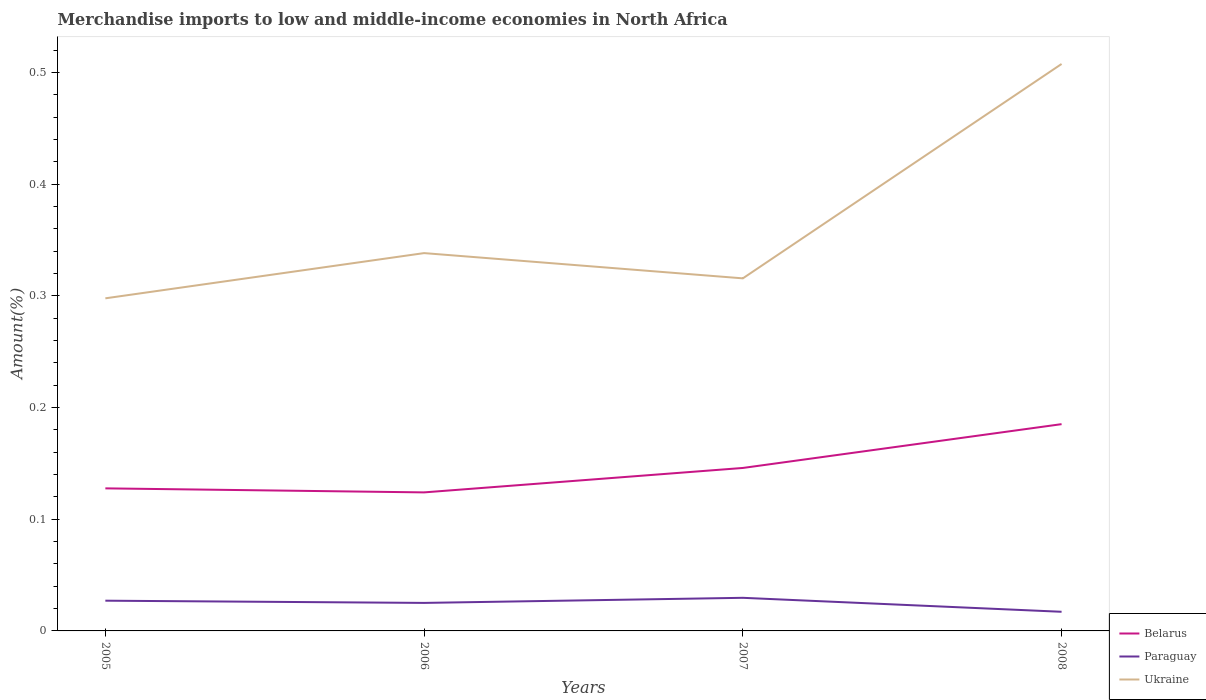How many different coloured lines are there?
Provide a succinct answer. 3. Across all years, what is the maximum percentage of amount earned from merchandise imports in Belarus?
Provide a short and direct response. 0.12. In which year was the percentage of amount earned from merchandise imports in Paraguay maximum?
Make the answer very short. 2008. What is the total percentage of amount earned from merchandise imports in Paraguay in the graph?
Keep it short and to the point. -0. What is the difference between the highest and the second highest percentage of amount earned from merchandise imports in Paraguay?
Make the answer very short. 0.01. What is the difference between the highest and the lowest percentage of amount earned from merchandise imports in Belarus?
Offer a very short reply. 2. Are the values on the major ticks of Y-axis written in scientific E-notation?
Keep it short and to the point. No. Does the graph contain any zero values?
Offer a very short reply. No. Does the graph contain grids?
Offer a terse response. No. Where does the legend appear in the graph?
Offer a very short reply. Bottom right. How many legend labels are there?
Your answer should be very brief. 3. What is the title of the graph?
Offer a very short reply. Merchandise imports to low and middle-income economies in North Africa. What is the label or title of the X-axis?
Make the answer very short. Years. What is the label or title of the Y-axis?
Offer a terse response. Amount(%). What is the Amount(%) of Belarus in 2005?
Keep it short and to the point. 0.13. What is the Amount(%) in Paraguay in 2005?
Provide a succinct answer. 0.03. What is the Amount(%) of Ukraine in 2005?
Your answer should be compact. 0.3. What is the Amount(%) of Belarus in 2006?
Make the answer very short. 0.12. What is the Amount(%) in Paraguay in 2006?
Provide a succinct answer. 0.03. What is the Amount(%) of Ukraine in 2006?
Offer a very short reply. 0.34. What is the Amount(%) in Belarus in 2007?
Ensure brevity in your answer.  0.15. What is the Amount(%) in Paraguay in 2007?
Offer a very short reply. 0.03. What is the Amount(%) in Ukraine in 2007?
Offer a very short reply. 0.32. What is the Amount(%) of Belarus in 2008?
Your response must be concise. 0.19. What is the Amount(%) in Paraguay in 2008?
Your answer should be very brief. 0.02. What is the Amount(%) in Ukraine in 2008?
Offer a terse response. 0.51. Across all years, what is the maximum Amount(%) in Belarus?
Provide a short and direct response. 0.19. Across all years, what is the maximum Amount(%) in Paraguay?
Keep it short and to the point. 0.03. Across all years, what is the maximum Amount(%) of Ukraine?
Offer a very short reply. 0.51. Across all years, what is the minimum Amount(%) in Belarus?
Provide a short and direct response. 0.12. Across all years, what is the minimum Amount(%) in Paraguay?
Provide a succinct answer. 0.02. Across all years, what is the minimum Amount(%) in Ukraine?
Your answer should be very brief. 0.3. What is the total Amount(%) of Belarus in the graph?
Your answer should be compact. 0.58. What is the total Amount(%) of Paraguay in the graph?
Provide a succinct answer. 0.1. What is the total Amount(%) in Ukraine in the graph?
Your answer should be very brief. 1.46. What is the difference between the Amount(%) of Belarus in 2005 and that in 2006?
Provide a succinct answer. 0. What is the difference between the Amount(%) of Paraguay in 2005 and that in 2006?
Offer a terse response. 0. What is the difference between the Amount(%) of Ukraine in 2005 and that in 2006?
Offer a terse response. -0.04. What is the difference between the Amount(%) of Belarus in 2005 and that in 2007?
Offer a very short reply. -0.02. What is the difference between the Amount(%) in Paraguay in 2005 and that in 2007?
Your answer should be compact. -0. What is the difference between the Amount(%) of Ukraine in 2005 and that in 2007?
Your response must be concise. -0.02. What is the difference between the Amount(%) in Belarus in 2005 and that in 2008?
Offer a terse response. -0.06. What is the difference between the Amount(%) in Paraguay in 2005 and that in 2008?
Make the answer very short. 0.01. What is the difference between the Amount(%) of Ukraine in 2005 and that in 2008?
Your response must be concise. -0.21. What is the difference between the Amount(%) in Belarus in 2006 and that in 2007?
Provide a short and direct response. -0.02. What is the difference between the Amount(%) of Paraguay in 2006 and that in 2007?
Provide a succinct answer. -0. What is the difference between the Amount(%) in Ukraine in 2006 and that in 2007?
Provide a succinct answer. 0.02. What is the difference between the Amount(%) in Belarus in 2006 and that in 2008?
Offer a very short reply. -0.06. What is the difference between the Amount(%) of Paraguay in 2006 and that in 2008?
Keep it short and to the point. 0.01. What is the difference between the Amount(%) of Ukraine in 2006 and that in 2008?
Your response must be concise. -0.17. What is the difference between the Amount(%) in Belarus in 2007 and that in 2008?
Keep it short and to the point. -0.04. What is the difference between the Amount(%) in Paraguay in 2007 and that in 2008?
Provide a short and direct response. 0.01. What is the difference between the Amount(%) in Ukraine in 2007 and that in 2008?
Provide a short and direct response. -0.19. What is the difference between the Amount(%) of Belarus in 2005 and the Amount(%) of Paraguay in 2006?
Make the answer very short. 0.1. What is the difference between the Amount(%) in Belarus in 2005 and the Amount(%) in Ukraine in 2006?
Your response must be concise. -0.21. What is the difference between the Amount(%) in Paraguay in 2005 and the Amount(%) in Ukraine in 2006?
Offer a very short reply. -0.31. What is the difference between the Amount(%) in Belarus in 2005 and the Amount(%) in Paraguay in 2007?
Your answer should be very brief. 0.1. What is the difference between the Amount(%) of Belarus in 2005 and the Amount(%) of Ukraine in 2007?
Make the answer very short. -0.19. What is the difference between the Amount(%) in Paraguay in 2005 and the Amount(%) in Ukraine in 2007?
Ensure brevity in your answer.  -0.29. What is the difference between the Amount(%) in Belarus in 2005 and the Amount(%) in Paraguay in 2008?
Provide a short and direct response. 0.11. What is the difference between the Amount(%) of Belarus in 2005 and the Amount(%) of Ukraine in 2008?
Provide a short and direct response. -0.38. What is the difference between the Amount(%) in Paraguay in 2005 and the Amount(%) in Ukraine in 2008?
Ensure brevity in your answer.  -0.48. What is the difference between the Amount(%) of Belarus in 2006 and the Amount(%) of Paraguay in 2007?
Keep it short and to the point. 0.09. What is the difference between the Amount(%) of Belarus in 2006 and the Amount(%) of Ukraine in 2007?
Ensure brevity in your answer.  -0.19. What is the difference between the Amount(%) in Paraguay in 2006 and the Amount(%) in Ukraine in 2007?
Keep it short and to the point. -0.29. What is the difference between the Amount(%) of Belarus in 2006 and the Amount(%) of Paraguay in 2008?
Give a very brief answer. 0.11. What is the difference between the Amount(%) in Belarus in 2006 and the Amount(%) in Ukraine in 2008?
Offer a terse response. -0.38. What is the difference between the Amount(%) in Paraguay in 2006 and the Amount(%) in Ukraine in 2008?
Provide a succinct answer. -0.48. What is the difference between the Amount(%) of Belarus in 2007 and the Amount(%) of Paraguay in 2008?
Your response must be concise. 0.13. What is the difference between the Amount(%) of Belarus in 2007 and the Amount(%) of Ukraine in 2008?
Your response must be concise. -0.36. What is the difference between the Amount(%) in Paraguay in 2007 and the Amount(%) in Ukraine in 2008?
Your response must be concise. -0.48. What is the average Amount(%) in Belarus per year?
Your response must be concise. 0.15. What is the average Amount(%) of Paraguay per year?
Your answer should be very brief. 0.02. What is the average Amount(%) of Ukraine per year?
Make the answer very short. 0.36. In the year 2005, what is the difference between the Amount(%) of Belarus and Amount(%) of Paraguay?
Your answer should be very brief. 0.1. In the year 2005, what is the difference between the Amount(%) in Belarus and Amount(%) in Ukraine?
Keep it short and to the point. -0.17. In the year 2005, what is the difference between the Amount(%) in Paraguay and Amount(%) in Ukraine?
Make the answer very short. -0.27. In the year 2006, what is the difference between the Amount(%) of Belarus and Amount(%) of Paraguay?
Make the answer very short. 0.1. In the year 2006, what is the difference between the Amount(%) in Belarus and Amount(%) in Ukraine?
Ensure brevity in your answer.  -0.21. In the year 2006, what is the difference between the Amount(%) in Paraguay and Amount(%) in Ukraine?
Provide a short and direct response. -0.31. In the year 2007, what is the difference between the Amount(%) in Belarus and Amount(%) in Paraguay?
Provide a short and direct response. 0.12. In the year 2007, what is the difference between the Amount(%) in Belarus and Amount(%) in Ukraine?
Provide a short and direct response. -0.17. In the year 2007, what is the difference between the Amount(%) in Paraguay and Amount(%) in Ukraine?
Provide a short and direct response. -0.29. In the year 2008, what is the difference between the Amount(%) in Belarus and Amount(%) in Paraguay?
Provide a short and direct response. 0.17. In the year 2008, what is the difference between the Amount(%) of Belarus and Amount(%) of Ukraine?
Your answer should be very brief. -0.32. In the year 2008, what is the difference between the Amount(%) of Paraguay and Amount(%) of Ukraine?
Keep it short and to the point. -0.49. What is the ratio of the Amount(%) in Belarus in 2005 to that in 2006?
Keep it short and to the point. 1.03. What is the ratio of the Amount(%) in Paraguay in 2005 to that in 2006?
Ensure brevity in your answer.  1.08. What is the ratio of the Amount(%) in Ukraine in 2005 to that in 2006?
Make the answer very short. 0.88. What is the ratio of the Amount(%) in Belarus in 2005 to that in 2007?
Ensure brevity in your answer.  0.87. What is the ratio of the Amount(%) of Paraguay in 2005 to that in 2007?
Offer a very short reply. 0.91. What is the ratio of the Amount(%) of Ukraine in 2005 to that in 2007?
Your response must be concise. 0.94. What is the ratio of the Amount(%) in Belarus in 2005 to that in 2008?
Make the answer very short. 0.69. What is the ratio of the Amount(%) in Paraguay in 2005 to that in 2008?
Provide a short and direct response. 1.58. What is the ratio of the Amount(%) in Ukraine in 2005 to that in 2008?
Ensure brevity in your answer.  0.59. What is the ratio of the Amount(%) of Belarus in 2006 to that in 2007?
Your answer should be compact. 0.85. What is the ratio of the Amount(%) of Paraguay in 2006 to that in 2007?
Provide a succinct answer. 0.85. What is the ratio of the Amount(%) of Ukraine in 2006 to that in 2007?
Your answer should be compact. 1.07. What is the ratio of the Amount(%) in Belarus in 2006 to that in 2008?
Offer a very short reply. 0.67. What is the ratio of the Amount(%) of Paraguay in 2006 to that in 2008?
Offer a very short reply. 1.46. What is the ratio of the Amount(%) in Ukraine in 2006 to that in 2008?
Make the answer very short. 0.67. What is the ratio of the Amount(%) of Belarus in 2007 to that in 2008?
Provide a succinct answer. 0.79. What is the ratio of the Amount(%) in Paraguay in 2007 to that in 2008?
Offer a very short reply. 1.73. What is the ratio of the Amount(%) of Ukraine in 2007 to that in 2008?
Give a very brief answer. 0.62. What is the difference between the highest and the second highest Amount(%) in Belarus?
Provide a short and direct response. 0.04. What is the difference between the highest and the second highest Amount(%) in Paraguay?
Ensure brevity in your answer.  0. What is the difference between the highest and the second highest Amount(%) of Ukraine?
Ensure brevity in your answer.  0.17. What is the difference between the highest and the lowest Amount(%) of Belarus?
Provide a short and direct response. 0.06. What is the difference between the highest and the lowest Amount(%) in Paraguay?
Offer a terse response. 0.01. What is the difference between the highest and the lowest Amount(%) in Ukraine?
Offer a very short reply. 0.21. 